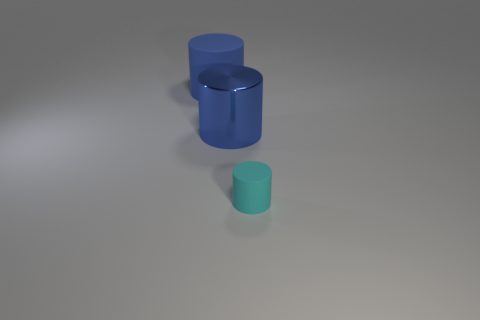There is another blue object that is the same shape as the shiny object; what material is it?
Keep it short and to the point. Rubber. How big is the matte object behind the matte cylinder in front of the rubber thing to the left of the metal cylinder?
Keep it short and to the point. Large. Is the blue rubber thing the same size as the blue shiny cylinder?
Make the answer very short. Yes. There is a large cylinder that is in front of the rubber object left of the small object; what is it made of?
Provide a short and direct response. Metal. Does the big blue object that is on the left side of the big metal cylinder have the same shape as the matte object that is to the right of the blue shiny thing?
Give a very brief answer. Yes. Is the number of blue metallic things left of the large blue shiny cylinder the same as the number of tiny cyan rubber cylinders?
Provide a short and direct response. No. Is there a blue matte cylinder that is on the left side of the matte object behind the tiny cyan object?
Keep it short and to the point. No. Is there anything else that is the same color as the large rubber thing?
Make the answer very short. Yes. Is the material of the blue cylinder that is right of the blue matte object the same as the cyan cylinder?
Provide a succinct answer. No. Are there an equal number of large blue rubber objects right of the large shiny thing and big metal objects that are on the left side of the small cylinder?
Give a very brief answer. No. 